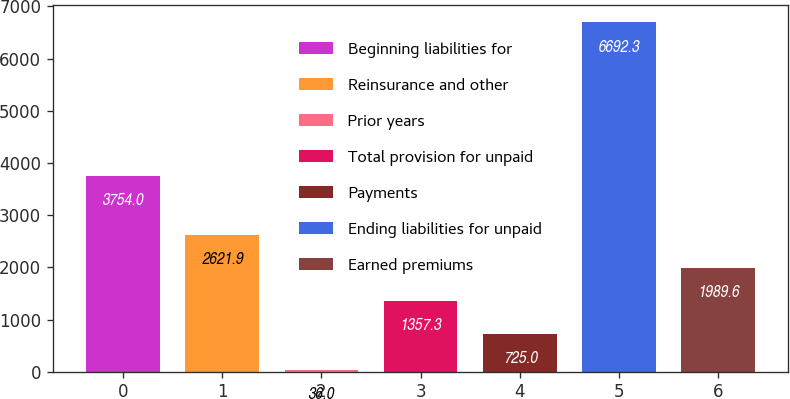Convert chart to OTSL. <chart><loc_0><loc_0><loc_500><loc_500><bar_chart><fcel>Beginning liabilities for<fcel>Reinsurance and other<fcel>Prior years<fcel>Total provision for unpaid<fcel>Payments<fcel>Ending liabilities for unpaid<fcel>Earned premiums<nl><fcel>3754<fcel>2621.9<fcel>36<fcel>1357.3<fcel>725<fcel>6692.3<fcel>1989.6<nl></chart> 